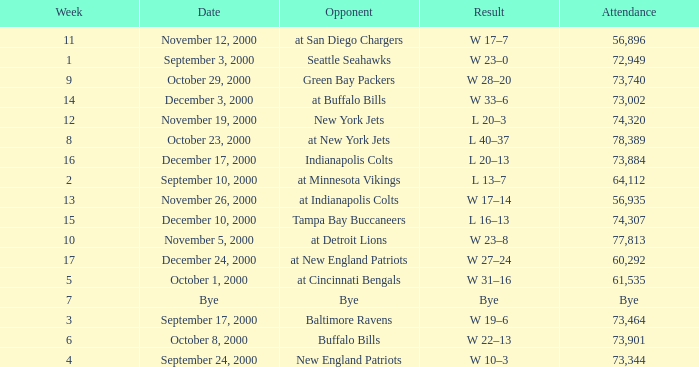What is the Attendance for a Week earlier than 16, and a Date of bye? Bye. 